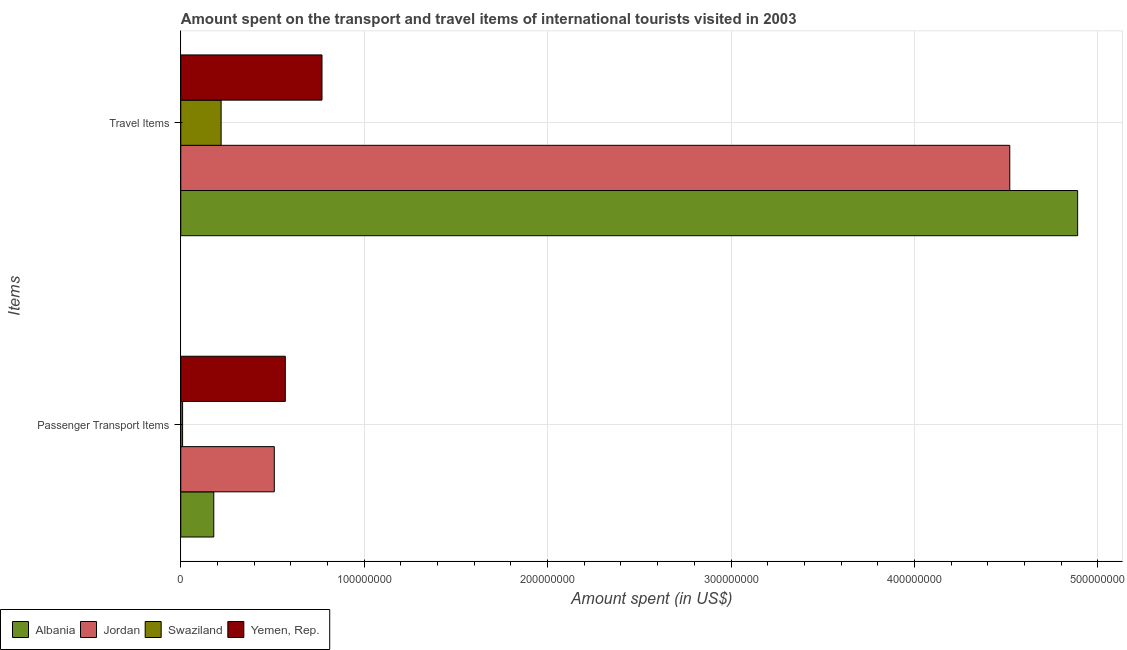How many different coloured bars are there?
Offer a terse response. 4. Are the number of bars on each tick of the Y-axis equal?
Your answer should be compact. Yes. How many bars are there on the 2nd tick from the bottom?
Offer a very short reply. 4. What is the label of the 2nd group of bars from the top?
Your answer should be very brief. Passenger Transport Items. What is the amount spent on passenger transport items in Jordan?
Offer a very short reply. 5.10e+07. Across all countries, what is the maximum amount spent on passenger transport items?
Offer a terse response. 5.70e+07. Across all countries, what is the minimum amount spent in travel items?
Offer a terse response. 2.20e+07. In which country was the amount spent in travel items maximum?
Provide a short and direct response. Albania. In which country was the amount spent in travel items minimum?
Give a very brief answer. Swaziland. What is the total amount spent in travel items in the graph?
Your response must be concise. 1.04e+09. What is the difference between the amount spent on passenger transport items in Yemen, Rep. and that in Jordan?
Offer a very short reply. 6.00e+06. What is the difference between the amount spent in travel items in Swaziland and the amount spent on passenger transport items in Jordan?
Keep it short and to the point. -2.90e+07. What is the average amount spent on passenger transport items per country?
Offer a terse response. 3.18e+07. What is the difference between the amount spent on passenger transport items and amount spent in travel items in Albania?
Ensure brevity in your answer.  -4.71e+08. What is the ratio of the amount spent on passenger transport items in Albania to that in Yemen, Rep.?
Give a very brief answer. 0.32. Is the amount spent on passenger transport items in Yemen, Rep. less than that in Swaziland?
Your answer should be compact. No. In how many countries, is the amount spent in travel items greater than the average amount spent in travel items taken over all countries?
Provide a succinct answer. 2. What does the 3rd bar from the top in Passenger Transport Items represents?
Ensure brevity in your answer.  Jordan. What does the 1st bar from the bottom in Passenger Transport Items represents?
Your answer should be compact. Albania. How many bars are there?
Give a very brief answer. 8. Are all the bars in the graph horizontal?
Give a very brief answer. Yes. How many countries are there in the graph?
Provide a short and direct response. 4. What is the difference between two consecutive major ticks on the X-axis?
Offer a very short reply. 1.00e+08. How many legend labels are there?
Ensure brevity in your answer.  4. What is the title of the graph?
Provide a succinct answer. Amount spent on the transport and travel items of international tourists visited in 2003. What is the label or title of the X-axis?
Your answer should be very brief. Amount spent (in US$). What is the label or title of the Y-axis?
Keep it short and to the point. Items. What is the Amount spent (in US$) in Albania in Passenger Transport Items?
Give a very brief answer. 1.80e+07. What is the Amount spent (in US$) of Jordan in Passenger Transport Items?
Make the answer very short. 5.10e+07. What is the Amount spent (in US$) of Swaziland in Passenger Transport Items?
Provide a short and direct response. 1.00e+06. What is the Amount spent (in US$) of Yemen, Rep. in Passenger Transport Items?
Your answer should be compact. 5.70e+07. What is the Amount spent (in US$) of Albania in Travel Items?
Offer a very short reply. 4.89e+08. What is the Amount spent (in US$) in Jordan in Travel Items?
Your answer should be very brief. 4.52e+08. What is the Amount spent (in US$) in Swaziland in Travel Items?
Provide a succinct answer. 2.20e+07. What is the Amount spent (in US$) of Yemen, Rep. in Travel Items?
Your answer should be compact. 7.70e+07. Across all Items, what is the maximum Amount spent (in US$) of Albania?
Offer a very short reply. 4.89e+08. Across all Items, what is the maximum Amount spent (in US$) of Jordan?
Offer a very short reply. 4.52e+08. Across all Items, what is the maximum Amount spent (in US$) of Swaziland?
Offer a very short reply. 2.20e+07. Across all Items, what is the maximum Amount spent (in US$) of Yemen, Rep.?
Your answer should be compact. 7.70e+07. Across all Items, what is the minimum Amount spent (in US$) in Albania?
Your answer should be compact. 1.80e+07. Across all Items, what is the minimum Amount spent (in US$) in Jordan?
Your response must be concise. 5.10e+07. Across all Items, what is the minimum Amount spent (in US$) in Swaziland?
Provide a succinct answer. 1.00e+06. Across all Items, what is the minimum Amount spent (in US$) in Yemen, Rep.?
Provide a short and direct response. 5.70e+07. What is the total Amount spent (in US$) of Albania in the graph?
Make the answer very short. 5.07e+08. What is the total Amount spent (in US$) in Jordan in the graph?
Provide a succinct answer. 5.03e+08. What is the total Amount spent (in US$) of Swaziland in the graph?
Make the answer very short. 2.30e+07. What is the total Amount spent (in US$) in Yemen, Rep. in the graph?
Give a very brief answer. 1.34e+08. What is the difference between the Amount spent (in US$) of Albania in Passenger Transport Items and that in Travel Items?
Ensure brevity in your answer.  -4.71e+08. What is the difference between the Amount spent (in US$) in Jordan in Passenger Transport Items and that in Travel Items?
Offer a terse response. -4.01e+08. What is the difference between the Amount spent (in US$) in Swaziland in Passenger Transport Items and that in Travel Items?
Your response must be concise. -2.10e+07. What is the difference between the Amount spent (in US$) in Yemen, Rep. in Passenger Transport Items and that in Travel Items?
Make the answer very short. -2.00e+07. What is the difference between the Amount spent (in US$) of Albania in Passenger Transport Items and the Amount spent (in US$) of Jordan in Travel Items?
Offer a terse response. -4.34e+08. What is the difference between the Amount spent (in US$) in Albania in Passenger Transport Items and the Amount spent (in US$) in Yemen, Rep. in Travel Items?
Offer a terse response. -5.90e+07. What is the difference between the Amount spent (in US$) in Jordan in Passenger Transport Items and the Amount spent (in US$) in Swaziland in Travel Items?
Give a very brief answer. 2.90e+07. What is the difference between the Amount spent (in US$) in Jordan in Passenger Transport Items and the Amount spent (in US$) in Yemen, Rep. in Travel Items?
Give a very brief answer. -2.60e+07. What is the difference between the Amount spent (in US$) of Swaziland in Passenger Transport Items and the Amount spent (in US$) of Yemen, Rep. in Travel Items?
Make the answer very short. -7.60e+07. What is the average Amount spent (in US$) in Albania per Items?
Provide a short and direct response. 2.54e+08. What is the average Amount spent (in US$) in Jordan per Items?
Provide a short and direct response. 2.52e+08. What is the average Amount spent (in US$) in Swaziland per Items?
Ensure brevity in your answer.  1.15e+07. What is the average Amount spent (in US$) in Yemen, Rep. per Items?
Your answer should be very brief. 6.70e+07. What is the difference between the Amount spent (in US$) of Albania and Amount spent (in US$) of Jordan in Passenger Transport Items?
Your response must be concise. -3.30e+07. What is the difference between the Amount spent (in US$) in Albania and Amount spent (in US$) in Swaziland in Passenger Transport Items?
Your answer should be very brief. 1.70e+07. What is the difference between the Amount spent (in US$) of Albania and Amount spent (in US$) of Yemen, Rep. in Passenger Transport Items?
Make the answer very short. -3.90e+07. What is the difference between the Amount spent (in US$) in Jordan and Amount spent (in US$) in Yemen, Rep. in Passenger Transport Items?
Provide a short and direct response. -6.00e+06. What is the difference between the Amount spent (in US$) in Swaziland and Amount spent (in US$) in Yemen, Rep. in Passenger Transport Items?
Give a very brief answer. -5.60e+07. What is the difference between the Amount spent (in US$) of Albania and Amount spent (in US$) of Jordan in Travel Items?
Your response must be concise. 3.70e+07. What is the difference between the Amount spent (in US$) of Albania and Amount spent (in US$) of Swaziland in Travel Items?
Keep it short and to the point. 4.67e+08. What is the difference between the Amount spent (in US$) in Albania and Amount spent (in US$) in Yemen, Rep. in Travel Items?
Give a very brief answer. 4.12e+08. What is the difference between the Amount spent (in US$) in Jordan and Amount spent (in US$) in Swaziland in Travel Items?
Your answer should be very brief. 4.30e+08. What is the difference between the Amount spent (in US$) of Jordan and Amount spent (in US$) of Yemen, Rep. in Travel Items?
Make the answer very short. 3.75e+08. What is the difference between the Amount spent (in US$) in Swaziland and Amount spent (in US$) in Yemen, Rep. in Travel Items?
Keep it short and to the point. -5.50e+07. What is the ratio of the Amount spent (in US$) of Albania in Passenger Transport Items to that in Travel Items?
Ensure brevity in your answer.  0.04. What is the ratio of the Amount spent (in US$) of Jordan in Passenger Transport Items to that in Travel Items?
Provide a short and direct response. 0.11. What is the ratio of the Amount spent (in US$) of Swaziland in Passenger Transport Items to that in Travel Items?
Your answer should be very brief. 0.05. What is the ratio of the Amount spent (in US$) in Yemen, Rep. in Passenger Transport Items to that in Travel Items?
Provide a short and direct response. 0.74. What is the difference between the highest and the second highest Amount spent (in US$) in Albania?
Provide a succinct answer. 4.71e+08. What is the difference between the highest and the second highest Amount spent (in US$) of Jordan?
Give a very brief answer. 4.01e+08. What is the difference between the highest and the second highest Amount spent (in US$) in Swaziland?
Your answer should be compact. 2.10e+07. What is the difference between the highest and the lowest Amount spent (in US$) in Albania?
Your answer should be very brief. 4.71e+08. What is the difference between the highest and the lowest Amount spent (in US$) of Jordan?
Offer a very short reply. 4.01e+08. What is the difference between the highest and the lowest Amount spent (in US$) of Swaziland?
Your response must be concise. 2.10e+07. What is the difference between the highest and the lowest Amount spent (in US$) in Yemen, Rep.?
Give a very brief answer. 2.00e+07. 